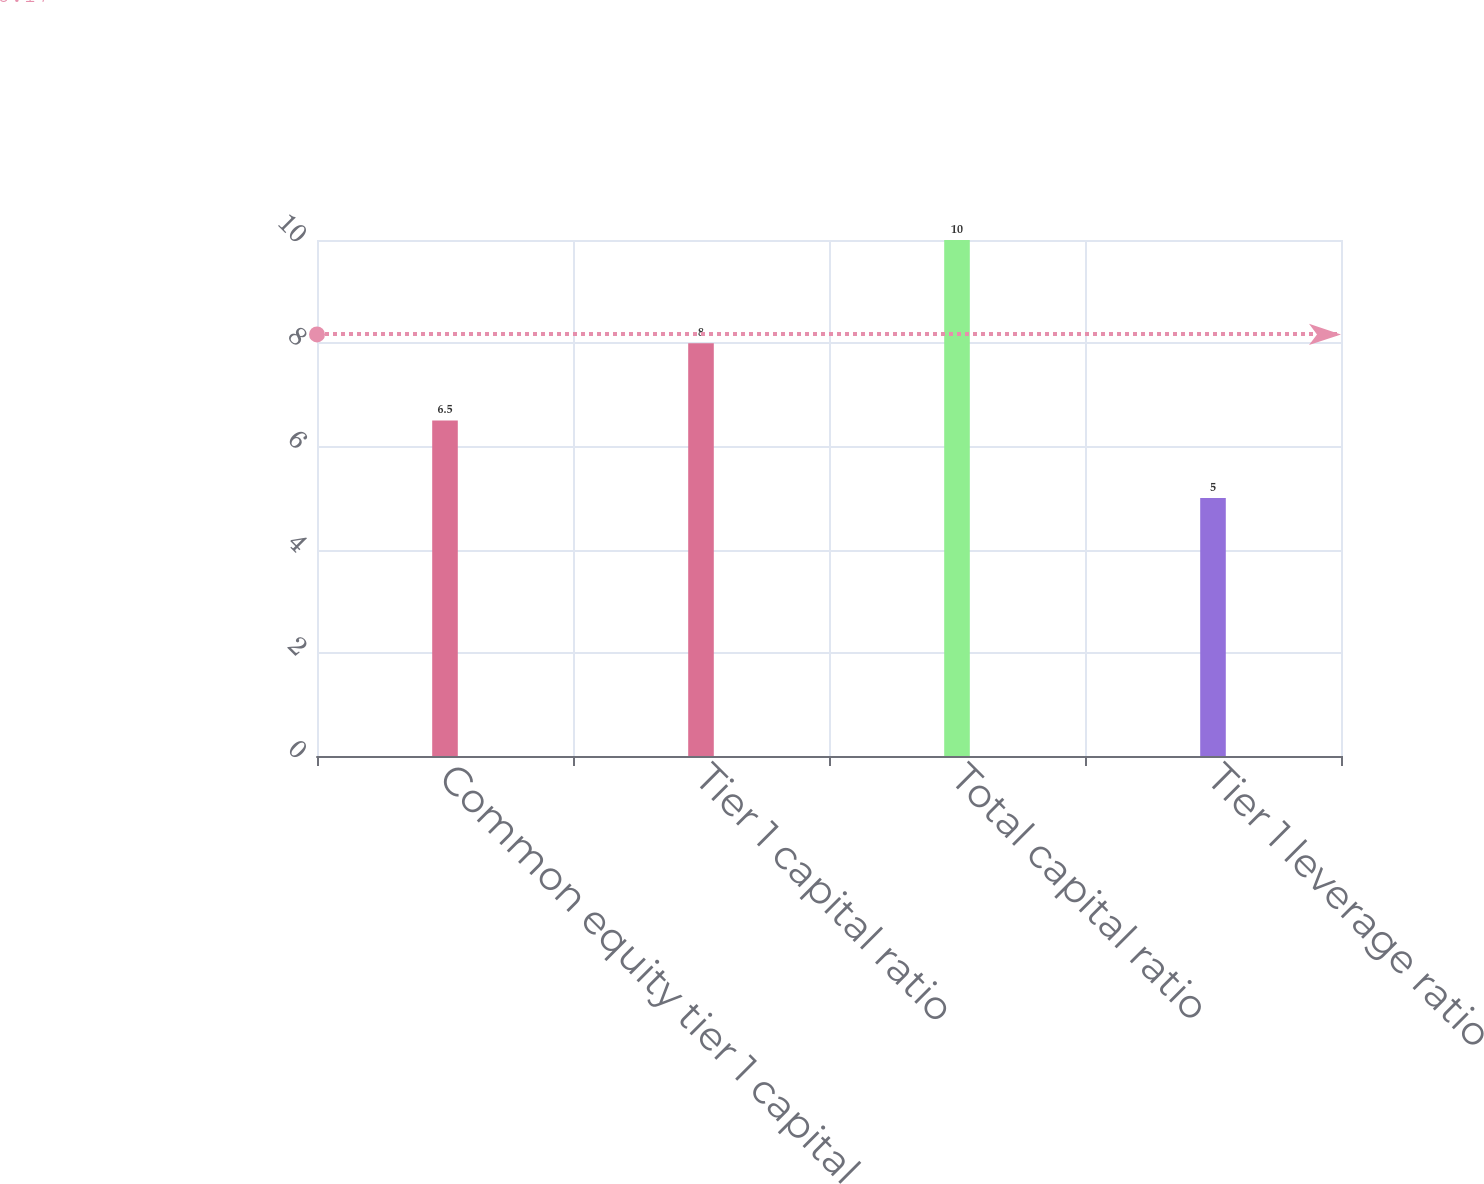Convert chart. <chart><loc_0><loc_0><loc_500><loc_500><bar_chart><fcel>Common equity tier 1 capital<fcel>Tier 1 capital ratio<fcel>Total capital ratio<fcel>Tier 1 leverage ratio<nl><fcel>6.5<fcel>8<fcel>10<fcel>5<nl></chart> 